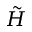Convert formula to latex. <formula><loc_0><loc_0><loc_500><loc_500>\tilde { H }</formula> 